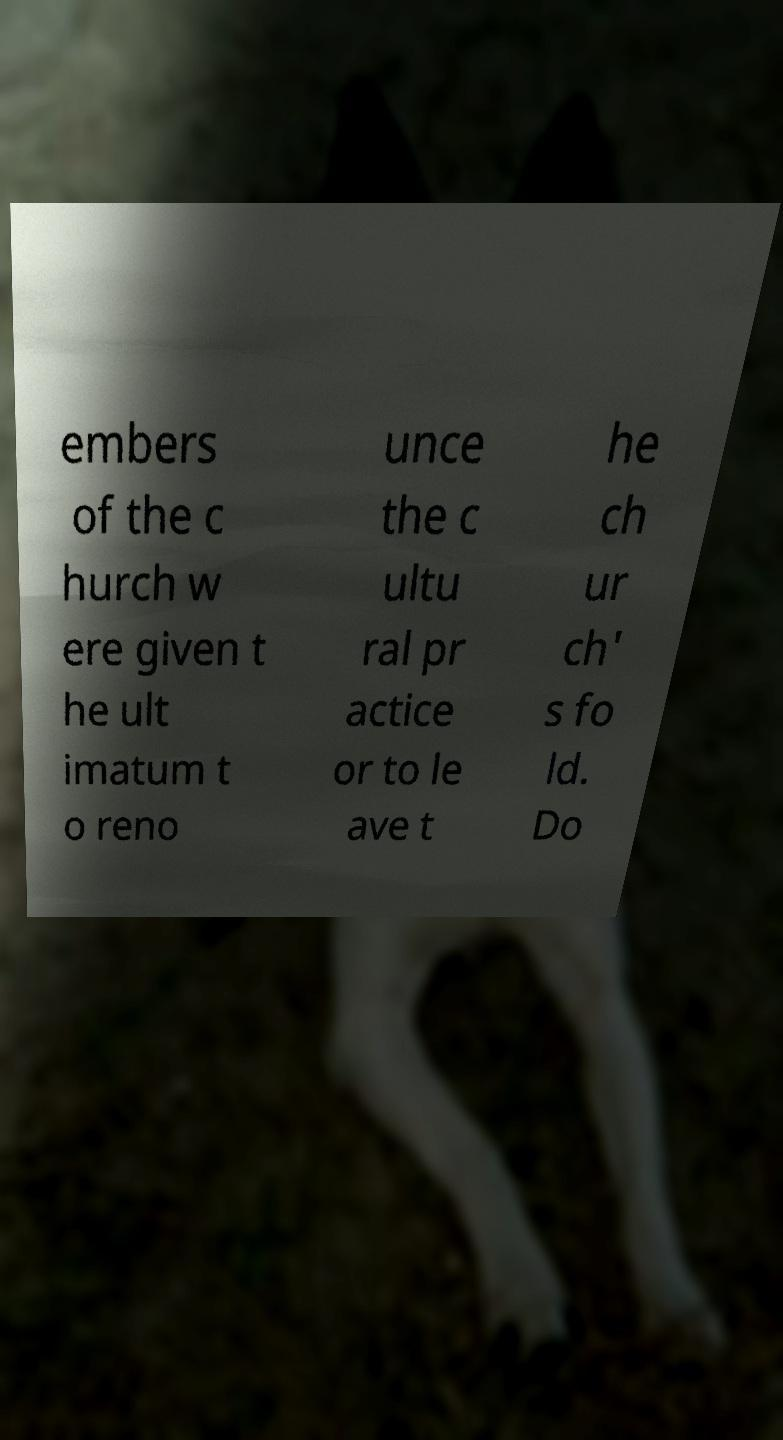What messages or text are displayed in this image? I need them in a readable, typed format. embers of the c hurch w ere given t he ult imatum t o reno unce the c ultu ral pr actice or to le ave t he ch ur ch' s fo ld. Do 